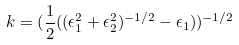<formula> <loc_0><loc_0><loc_500><loc_500>k = ( \frac { 1 } { 2 } ( ( \epsilon _ { 1 } ^ { 2 } + \epsilon _ { 2 } ^ { 2 } ) ^ { - 1 / 2 } - \epsilon _ { 1 } ) ) ^ { - 1 / 2 }</formula> 